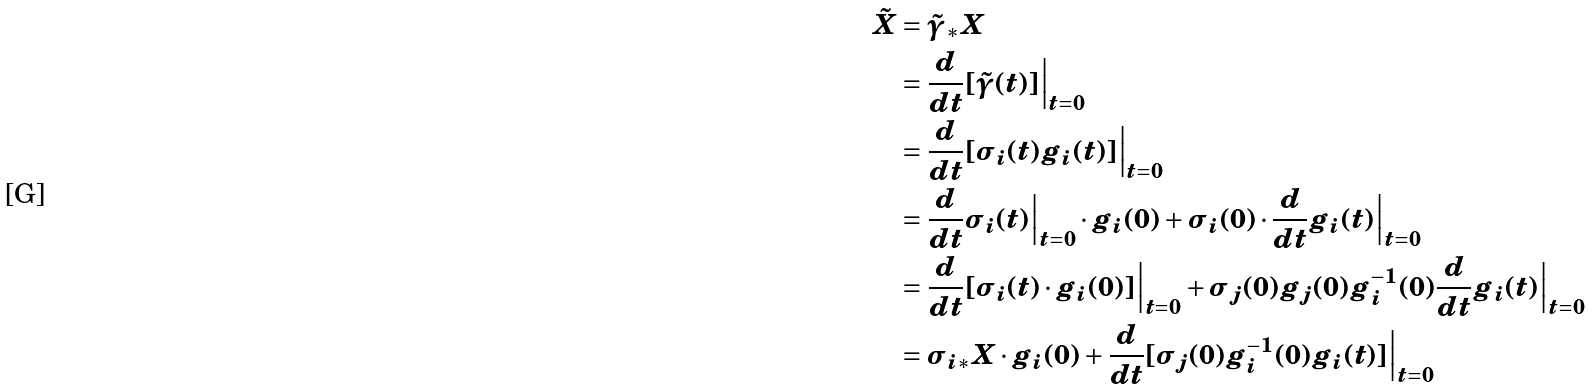<formula> <loc_0><loc_0><loc_500><loc_500>\tilde { X } & = \tilde { \gamma } _ { * } X \\ & = \frac { d } { d t } [ \tilde { \gamma } ( t ) ] \Big | _ { t = 0 } \\ & = \frac { d } { d t } [ \sigma _ { i } ( t ) g _ { i } ( t ) ] \Big | _ { t = 0 } \\ & = \frac { d } { d t } \sigma _ { i } ( t ) \Big | _ { t = 0 } \cdot g _ { i } ( 0 ) + \sigma _ { i } ( 0 ) \cdot \frac { d } { d t } g _ { i } ( t ) \Big | _ { t = 0 } \\ & = \frac { d } { d t } [ \sigma _ { i } ( t ) \cdot g _ { i } ( 0 ) ] \Big | _ { t = 0 } + \sigma _ { j } ( 0 ) g _ { j } ( 0 ) g _ { i } ^ { - 1 } ( 0 ) \frac { d } { d t } g _ { i } ( t ) \Big | _ { t = 0 } \\ & = \sigma _ { i * } X \cdot g _ { i } ( 0 ) + \frac { d } { d t } [ \sigma _ { j } ( 0 ) g _ { i } ^ { - 1 } ( 0 ) g _ { i } ( t ) ] \Big | _ { t = 0 }</formula> 